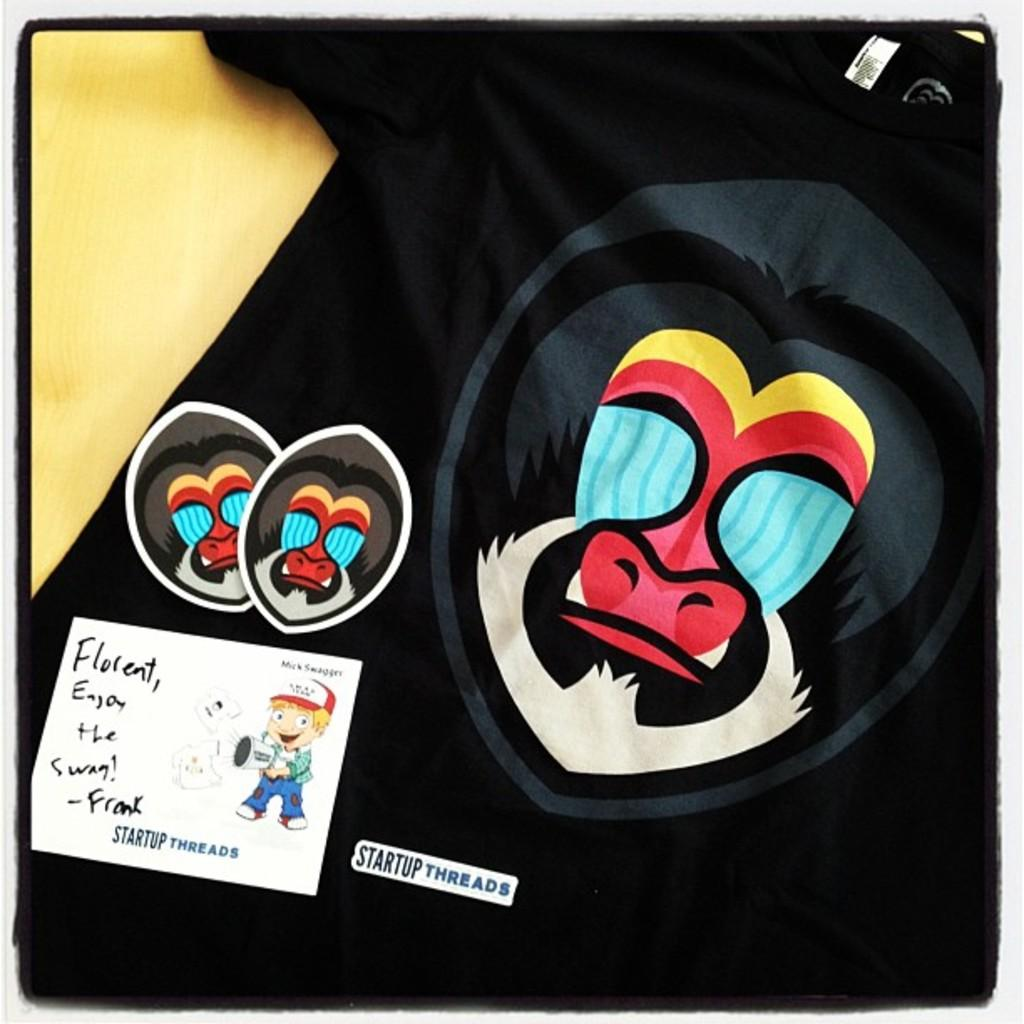What is the main subject in the foreground of the image? There is a black T-shirt in the foreground of the image. What design or pattern is on the T-shirt? There are symbols of monkeys on the T-shirt. Is there any other prominent feature on the T-shirt? Yes, there is a white rectangle box poster on the T-shirt. What type of frame is around the monkeys on the T-shirt? There is no frame around the monkeys on the T-shirt; the monkeys are part of the design or pattern on the T-shirt. 